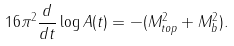Convert formula to latex. <formula><loc_0><loc_0><loc_500><loc_500>1 6 \pi ^ { 2 } \frac { d } { d t } \log A ( t ) = - ( M _ { t o p } ^ { 2 } + M _ { b } ^ { 2 } ) .</formula> 